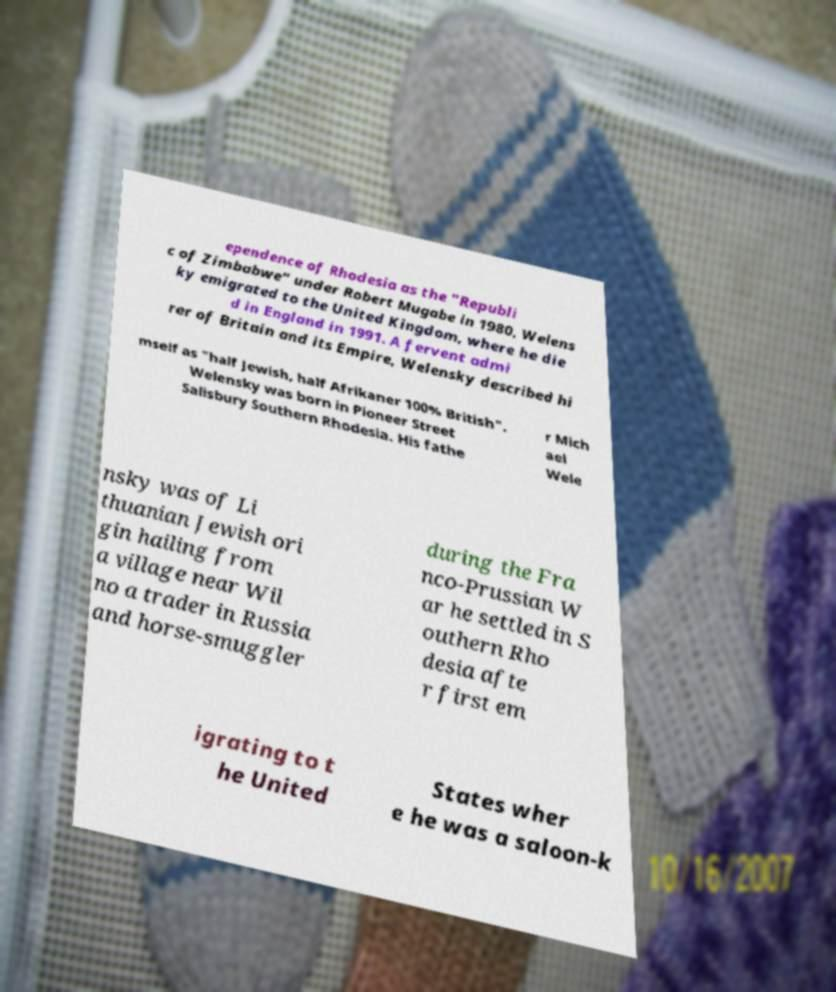I need the written content from this picture converted into text. Can you do that? ependence of Rhodesia as the "Republi c of Zimbabwe" under Robert Mugabe in 1980, Welens ky emigrated to the United Kingdom, where he die d in England in 1991. A fervent admi rer of Britain and its Empire, Welensky described hi mself as "half Jewish, half Afrikaner 100% British". Welensky was born in Pioneer Street Salisbury Southern Rhodesia. His fathe r Mich ael Wele nsky was of Li thuanian Jewish ori gin hailing from a village near Wil no a trader in Russia and horse-smuggler during the Fra nco-Prussian W ar he settled in S outhern Rho desia afte r first em igrating to t he United States wher e he was a saloon-k 